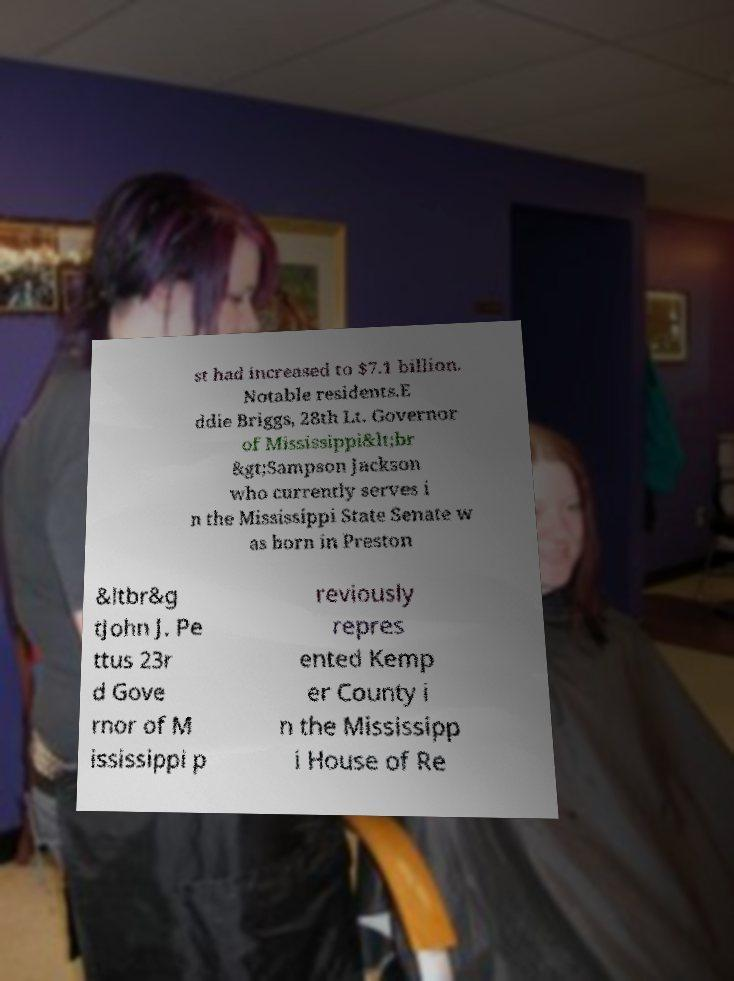I need the written content from this picture converted into text. Can you do that? st had increased to $7.1 billion. Notable residents.E ddie Briggs, 28th Lt. Governor of Mississippi&lt;br &gt;Sampson Jackson who currently serves i n the Mississippi State Senate w as born in Preston &ltbr&g tJohn J. Pe ttus 23r d Gove rnor of M ississippi p reviously repres ented Kemp er County i n the Mississipp i House of Re 